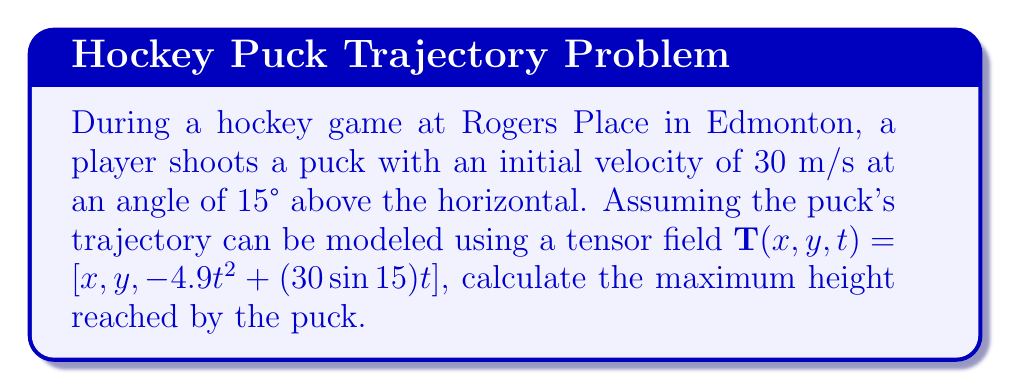Provide a solution to this math problem. To find the maximum height reached by the hockey puck, we need to analyze the y-component of the tensor field $\mathbf{T}(x,y,t)$.

1. The y-component of the trajectory is given by:
   $$y(t) = -4.9t^2 + (30\sin 15°)t$$

2. Calculate $\sin 15°$:
   $$\sin 15° \approx 0.2588$$

3. Substitute this value into the equation:
   $$y(t) = -4.9t^2 + (30 \cdot 0.2588)t = -4.9t^2 + 7.764t$$

4. To find the maximum height, we need to find the time when the vertical velocity is zero:
   $$\frac{dy}{dt} = -9.8t + 7.764 = 0$$

5. Solve for t:
   $$t = \frac{7.764}{9.8} \approx 0.7922 \text{ seconds}$$

6. Substitute this time back into the y(t) equation to find the maximum height:
   $$y_{max} = -4.9(0.7922)^2 + 7.764(0.7922) \approx 3.0766 \text{ meters}$$

Therefore, the maximum height reached by the puck is approximately 3.08 meters.
Answer: 3.08 m 